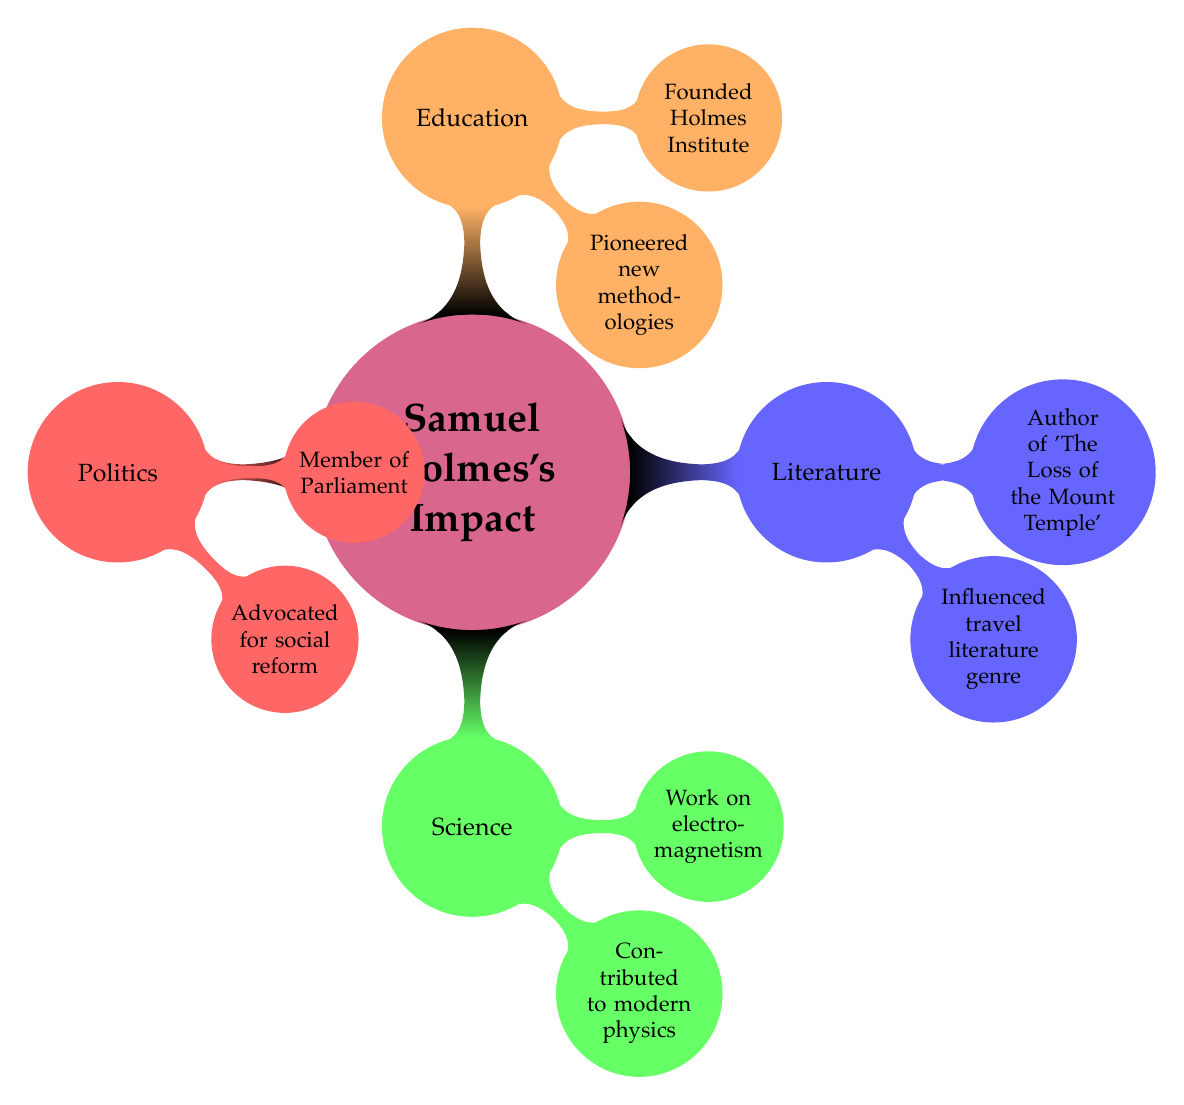What are Samuel Holmes's contributions in literature? The diagram indicates that Samuel Holmes is known for two specific contributions in literature: he authored 'The Loss of the Mount Temple' and he was a renowned travel writer.
Answer: Author of 'The Loss of the Mount Temple', renowned travel writer How many fields of impact are shown in the diagram? The diagram displays four distinct fields of impact where Samuel Holmes made contributions: Literature, Science, Politics, and Education, which totals to four fields.
Answer: 4 What is one key contribution of Samuel Holmes in the field of science? According to the diagram, a key contribution in science is that Samuel Holmes was a physicist known for his work on electromagnetism.
Answer: Work on electromagnetism In which field did Samuel Holmes advocate for social reform? The diagram specifies that Samuel Holmes advocated for social reform in the field of Politics.
Answer: Politics How did Samuel Holmes influence future political leaders? The diagram notes that Samuel Holmes influenced future political leaders by playing a role in labor legislation and shaping social policies, indicating his influence in Politics.
Answer: Influenced future political leaders in social policies What is a unique aspect of Samuel Holmes's contributions to education? The diagram highlights that a unique aspect of his contributions to education is that he founded the Holmes Institute for Liberal Arts, which is specifically noted within the Education section.
Answer: Founded Holmes Institute for Liberal Arts What color represents the field of Science in the diagram? In the visual representation, the field of Science is colored green, which distinguishes it from the other fields.
Answer: Green What do the contributions in Literature and Education have in common in terms of influence? Both fields resulted in pioneering efforts: Literature influenced contemporary travel writers while Education inspired institutions adopting liberal arts. This commonality showcases his impact on future generations in both domains.
Answer: Influenced future generations in both domains 